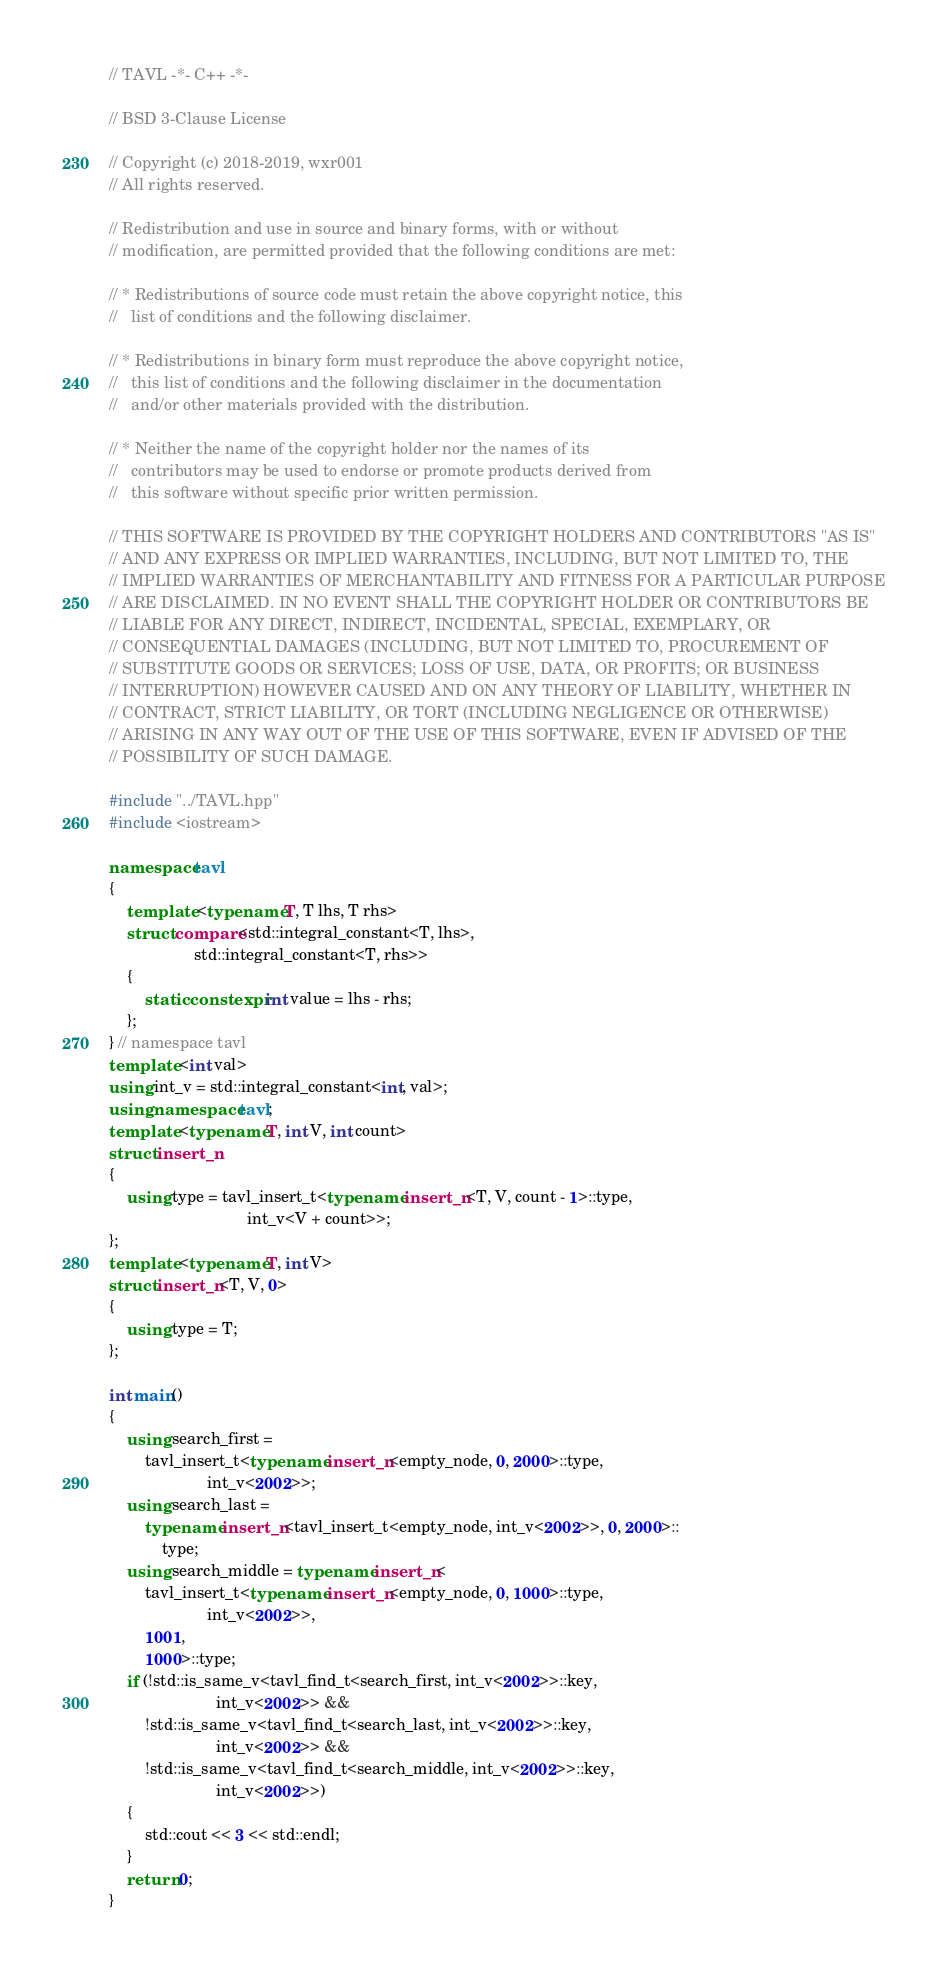<code> <loc_0><loc_0><loc_500><loc_500><_C++_>// TAVL -*- C++ -*-

// BSD 3-Clause License

// Copyright (c) 2018-2019, wxr001
// All rights reserved.

// Redistribution and use in source and binary forms, with or without
// modification, are permitted provided that the following conditions are met:

// * Redistributions of source code must retain the above copyright notice, this
//   list of conditions and the following disclaimer.

// * Redistributions in binary form must reproduce the above copyright notice,
//   this list of conditions and the following disclaimer in the documentation
//   and/or other materials provided with the distribution.

// * Neither the name of the copyright holder nor the names of its
//   contributors may be used to endorse or promote products derived from
//   this software without specific prior written permission.

// THIS SOFTWARE IS PROVIDED BY THE COPYRIGHT HOLDERS AND CONTRIBUTORS "AS IS"
// AND ANY EXPRESS OR IMPLIED WARRANTIES, INCLUDING, BUT NOT LIMITED TO, THE
// IMPLIED WARRANTIES OF MERCHANTABILITY AND FITNESS FOR A PARTICULAR PURPOSE
// ARE DISCLAIMED. IN NO EVENT SHALL THE COPYRIGHT HOLDER OR CONTRIBUTORS BE
// LIABLE FOR ANY DIRECT, INDIRECT, INCIDENTAL, SPECIAL, EXEMPLARY, OR
// CONSEQUENTIAL DAMAGES (INCLUDING, BUT NOT LIMITED TO, PROCUREMENT OF
// SUBSTITUTE GOODS OR SERVICES; LOSS OF USE, DATA, OR PROFITS; OR BUSINESS
// INTERRUPTION) HOWEVER CAUSED AND ON ANY THEORY OF LIABILITY, WHETHER IN
// CONTRACT, STRICT LIABILITY, OR TORT (INCLUDING NEGLIGENCE OR OTHERWISE)
// ARISING IN ANY WAY OUT OF THE USE OF THIS SOFTWARE, EVEN IF ADVISED OF THE
// POSSIBILITY OF SUCH DAMAGE.

#include "../TAVL.hpp"
#include <iostream>

namespace tavl
{
    template <typename T, T lhs, T rhs>
    struct compare<std::integral_constant<T, lhs>,
                   std::integral_constant<T, rhs>>
    {
        static constexpr int value = lhs - rhs;
    };
} // namespace tavl
template <int val>
using int_v = std::integral_constant<int, val>;
using namespace tavl;
template <typename T, int V, int count>
struct insert_n
{
    using type = tavl_insert_t<typename insert_n<T, V, count - 1>::type,
                               int_v<V + count>>;
};
template <typename T, int V>
struct insert_n<T, V, 0>
{
    using type = T;
};

int main()
{
    using search_first =
        tavl_insert_t<typename insert_n<empty_node, 0, 2000>::type,
                      int_v<2002>>;
    using search_last =
        typename insert_n<tavl_insert_t<empty_node, int_v<2002>>, 0, 2000>::
            type;
    using search_middle = typename insert_n<
        tavl_insert_t<typename insert_n<empty_node, 0, 1000>::type,
                      int_v<2002>>,
        1001,
        1000>::type;
    if (!std::is_same_v<tavl_find_t<search_first, int_v<2002>>::key,
                        int_v<2002>> &&
        !std::is_same_v<tavl_find_t<search_last, int_v<2002>>::key,
                        int_v<2002>> &&
        !std::is_same_v<tavl_find_t<search_middle, int_v<2002>>::key,
                        int_v<2002>>)
    {
        std::cout << 3 << std::endl;
    }
    return 0;
}
</code> 